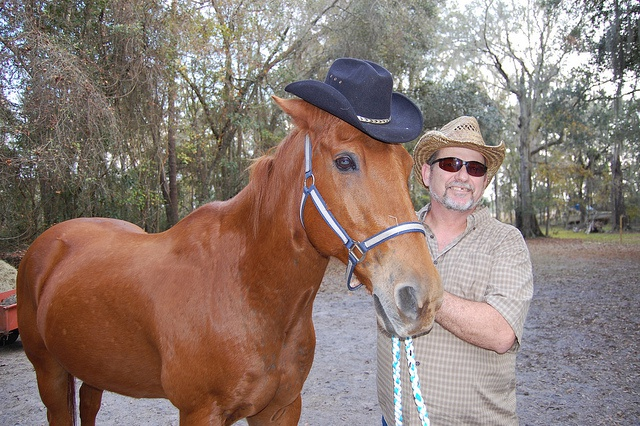Describe the objects in this image and their specific colors. I can see horse in gray, brown, and maroon tones and people in gray, darkgray, and lightgray tones in this image. 